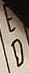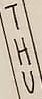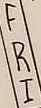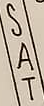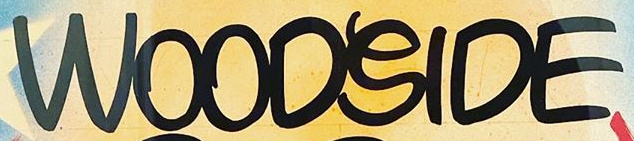Read the text from these images in sequence, separated by a semicolon. ED; THU; FRI; SAT; WOODSIDE 